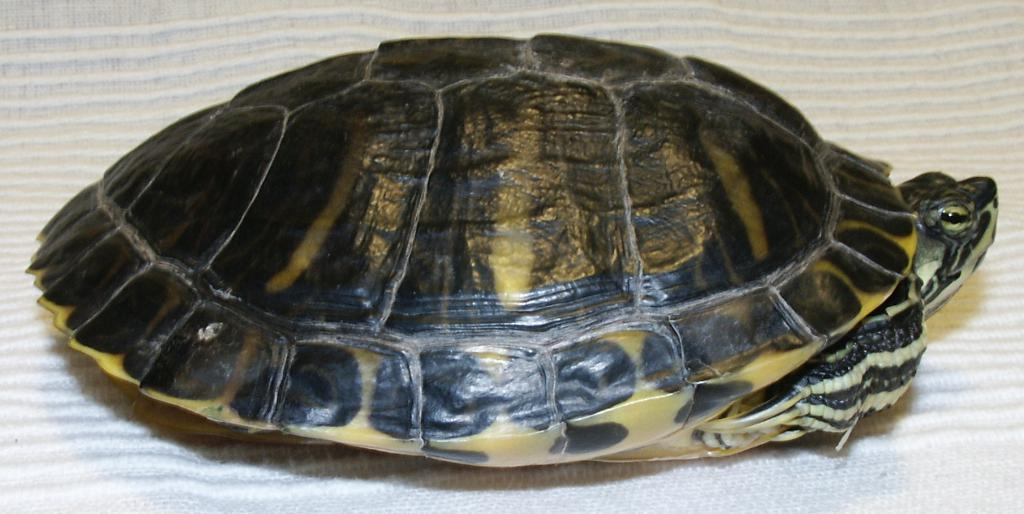What type of animal is in the image? There is a turtle in the image. What is the turtle resting on? The turtle is on a cloth. What type of glue is being used to hold the sand in the image? There is no glue or sand present in the image; it only features a turtle on a cloth. 